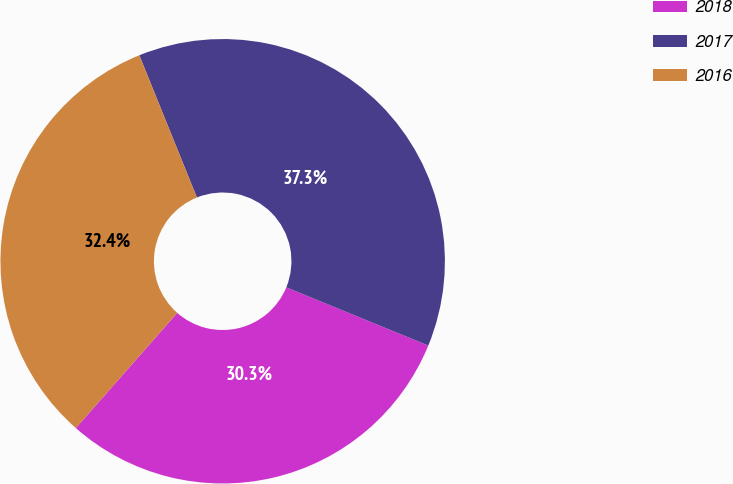Convert chart. <chart><loc_0><loc_0><loc_500><loc_500><pie_chart><fcel>2018<fcel>2017<fcel>2016<nl><fcel>30.3%<fcel>37.31%<fcel>32.39%<nl></chart> 